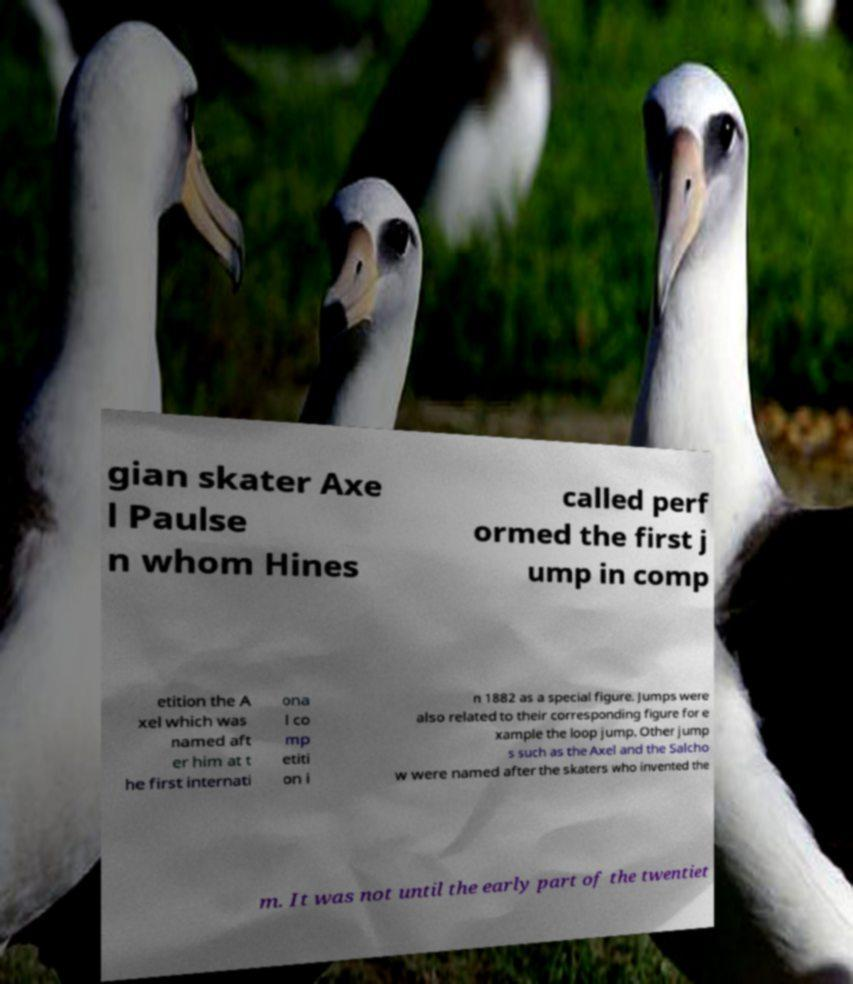What messages or text are displayed in this image? I need them in a readable, typed format. gian skater Axe l Paulse n whom Hines called perf ormed the first j ump in comp etition the A xel which was named aft er him at t he first internati ona l co mp etiti on i n 1882 as a special figure. Jumps were also related to their corresponding figure for e xample the loop jump. Other jump s such as the Axel and the Salcho w were named after the skaters who invented the m. It was not until the early part of the twentiet 